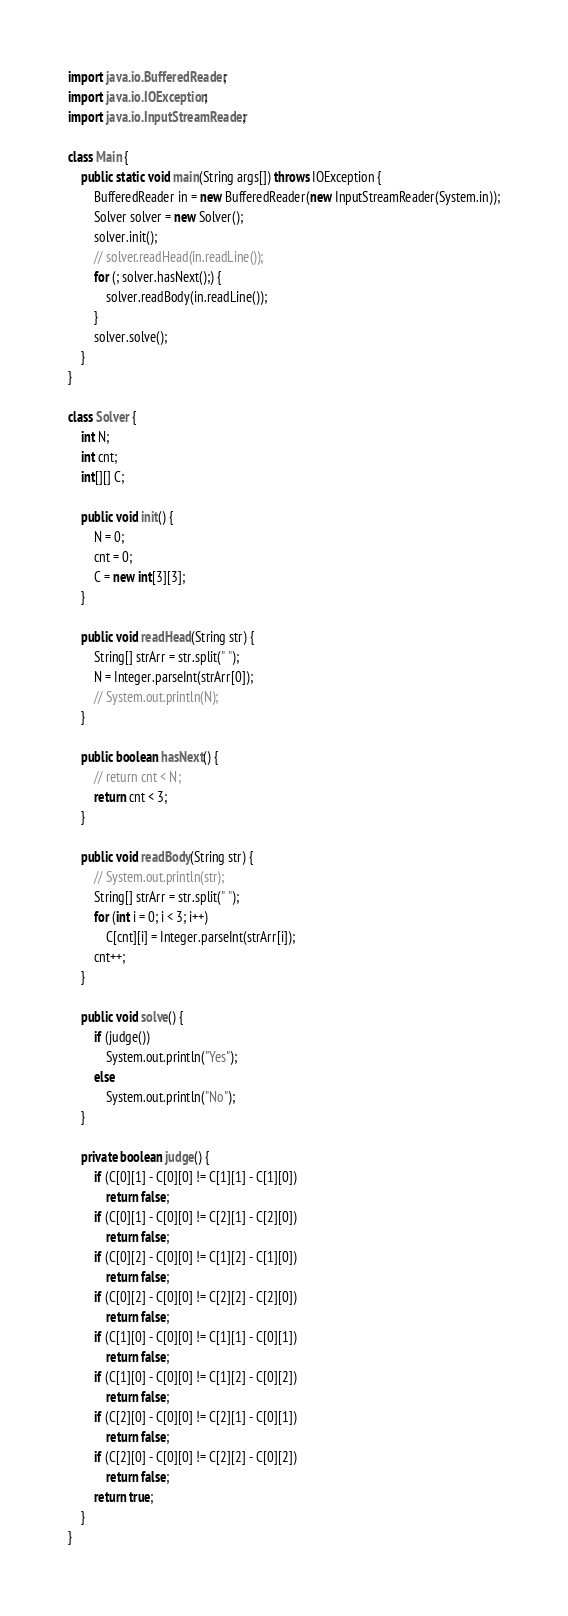<code> <loc_0><loc_0><loc_500><loc_500><_Java_>import java.io.BufferedReader;
import java.io.IOException;
import java.io.InputStreamReader;

class Main {
	public static void main(String args[]) throws IOException {
		BufferedReader in = new BufferedReader(new InputStreamReader(System.in));
		Solver solver = new Solver();
		solver.init();
		// solver.readHead(in.readLine());
		for (; solver.hasNext();) {
			solver.readBody(in.readLine());
		}
		solver.solve();
	}
}

class Solver {
	int N;
	int cnt;
	int[][] C;

	public void init() {
		N = 0;
		cnt = 0;
		C = new int[3][3];
	}

	public void readHead(String str) {
		String[] strArr = str.split(" ");
		N = Integer.parseInt(strArr[0]);
		// System.out.println(N);
	}

	public boolean hasNext() {
		// return cnt < N;
		return cnt < 3;
	}

	public void readBody(String str) {
		// System.out.println(str);
		String[] strArr = str.split(" ");
		for (int i = 0; i < 3; i++)
			C[cnt][i] = Integer.parseInt(strArr[i]);
		cnt++;
	}

	public void solve() {
		if (judge())
			System.out.println("Yes");
		else
			System.out.println("No");
	}

	private boolean judge() {
		if (C[0][1] - C[0][0] != C[1][1] - C[1][0])
			return false;
		if (C[0][1] - C[0][0] != C[2][1] - C[2][0])
			return false;
		if (C[0][2] - C[0][0] != C[1][2] - C[1][0])
			return false;
		if (C[0][2] - C[0][0] != C[2][2] - C[2][0])
			return false;
		if (C[1][0] - C[0][0] != C[1][1] - C[0][1])
			return false;
		if (C[1][0] - C[0][0] != C[1][2] - C[0][2])
			return false;
		if (C[2][0] - C[0][0] != C[2][1] - C[0][1])
			return false;
		if (C[2][0] - C[0][0] != C[2][2] - C[0][2])
			return false;
		return true;
	}
}
</code> 